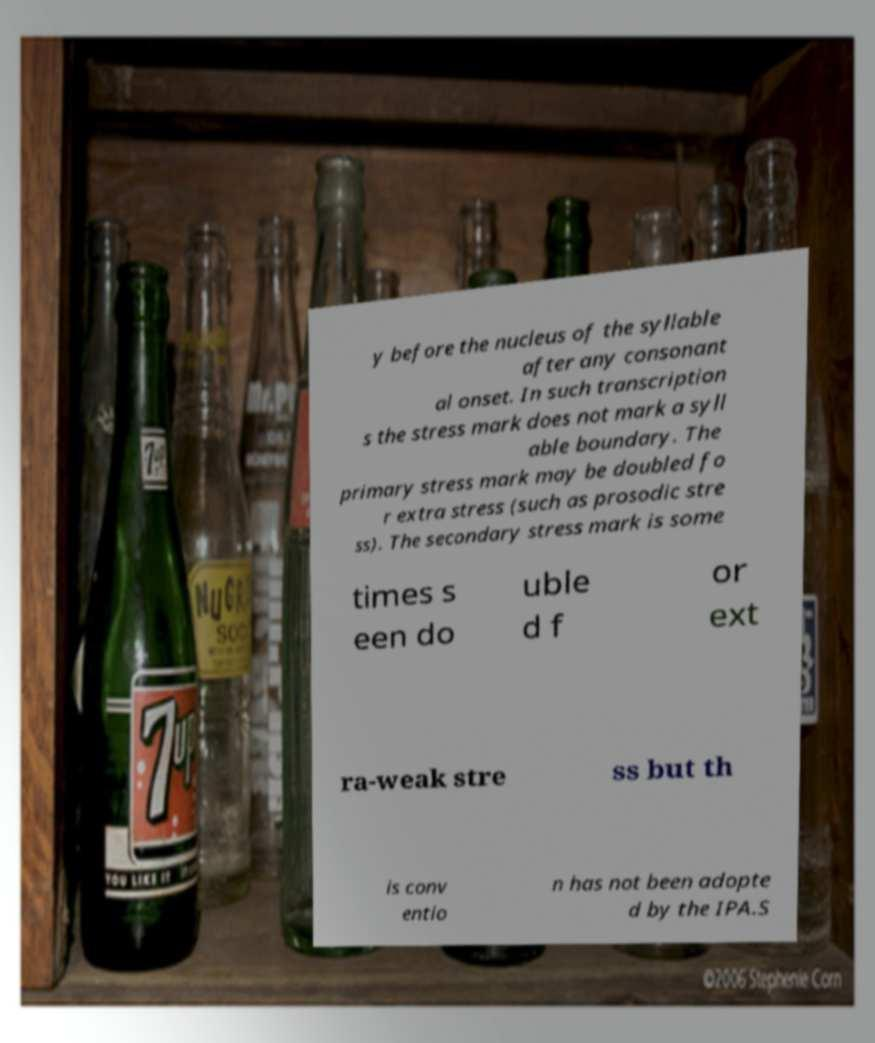There's text embedded in this image that I need extracted. Can you transcribe it verbatim? y before the nucleus of the syllable after any consonant al onset. In such transcription s the stress mark does not mark a syll able boundary. The primary stress mark may be doubled fo r extra stress (such as prosodic stre ss). The secondary stress mark is some times s een do uble d f or ext ra-weak stre ss but th is conv entio n has not been adopte d by the IPA.S 